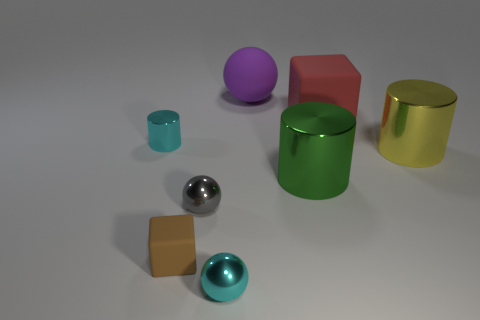Add 2 big brown rubber cubes. How many objects exist? 10 Subtract all cylinders. How many objects are left? 5 Add 1 big shiny cylinders. How many big shiny cylinders are left? 3 Add 4 large rubber spheres. How many large rubber spheres exist? 5 Subtract 0 purple cubes. How many objects are left? 8 Subtract all gray balls. Subtract all large matte balls. How many objects are left? 6 